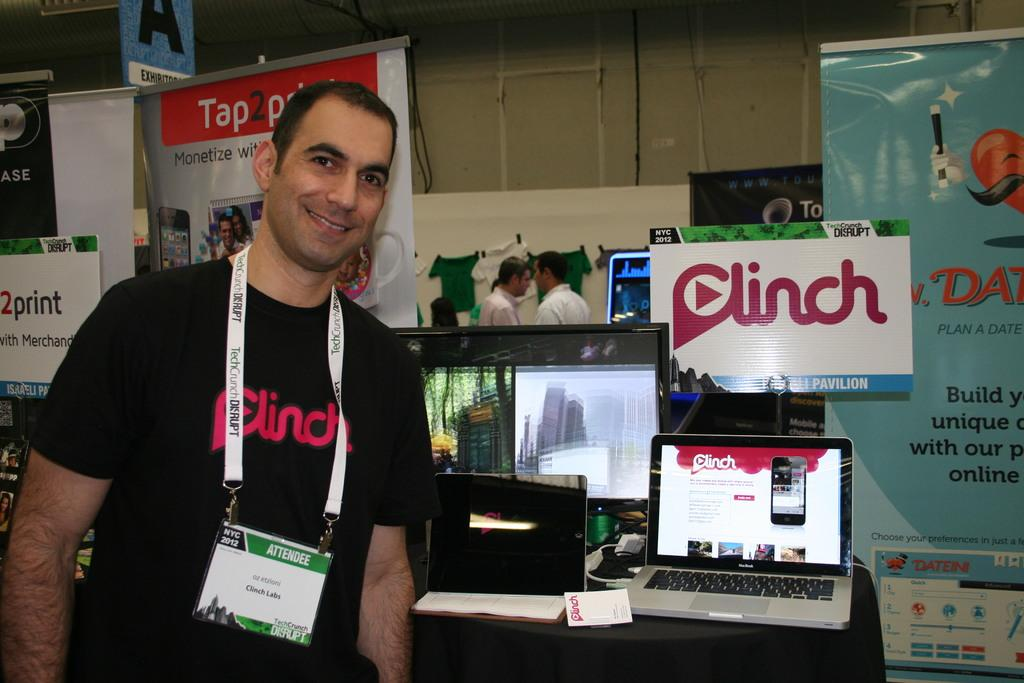What is the main subject of the image? There is a person standing in the image. What objects are present on the table in the image? There are many laptops on a table, and there is a system on the table. What can be seen in the background of the image? There are banners visible in the background, and there are two persons standing in the background. What type of duck can be seen on the front of the system in the image? There is no duck present on the front of the system or in the image. 